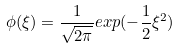Convert formula to latex. <formula><loc_0><loc_0><loc_500><loc_500>\phi ( \xi ) = \frac { 1 } { \sqrt { 2 \pi } } e x p ( - \frac { 1 } { 2 } \xi ^ { 2 } )</formula> 